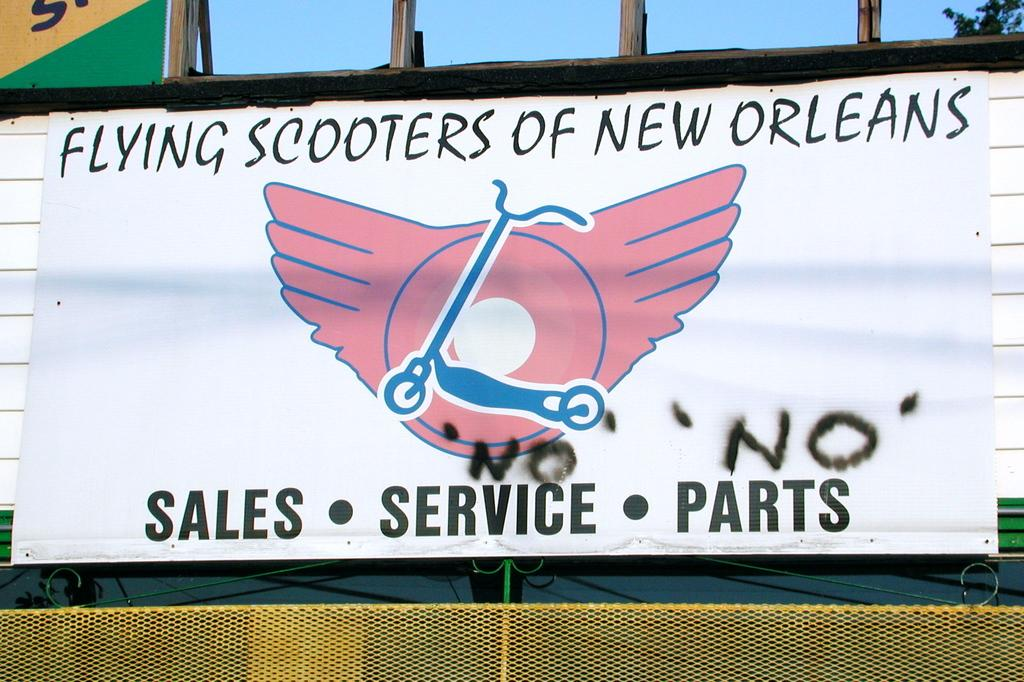Provide a one-sentence caption for the provided image. a banner with pink wings logo for flying scooters of new orleans. 